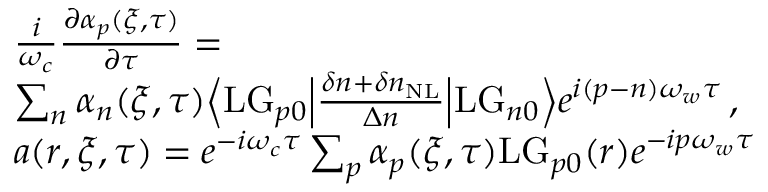Convert formula to latex. <formula><loc_0><loc_0><loc_500><loc_500>\begin{array} { r l } & { \frac { i } { \omega _ { c } } \frac { \partial \alpha _ { p } ( \xi , \tau ) } { \partial \tau } = } \\ & { \sum _ { n } \alpha _ { n } ( \xi , \tau ) \left \langle L G _ { p 0 } \left | \frac { \delta n + \delta n _ { N L } } { \Delta n } \right | L G _ { n 0 } \right \rangle e ^ { i ( p - n ) \omega _ { w } \tau } \, , } \\ & { a ( r , \xi , \tau ) = e ^ { - i \omega _ { c } \tau } \sum _ { p } \alpha _ { p } ( \xi , \tau ) L G _ { p 0 } ( r ) e ^ { - i p \omega _ { w } \tau } } \end{array}</formula> 